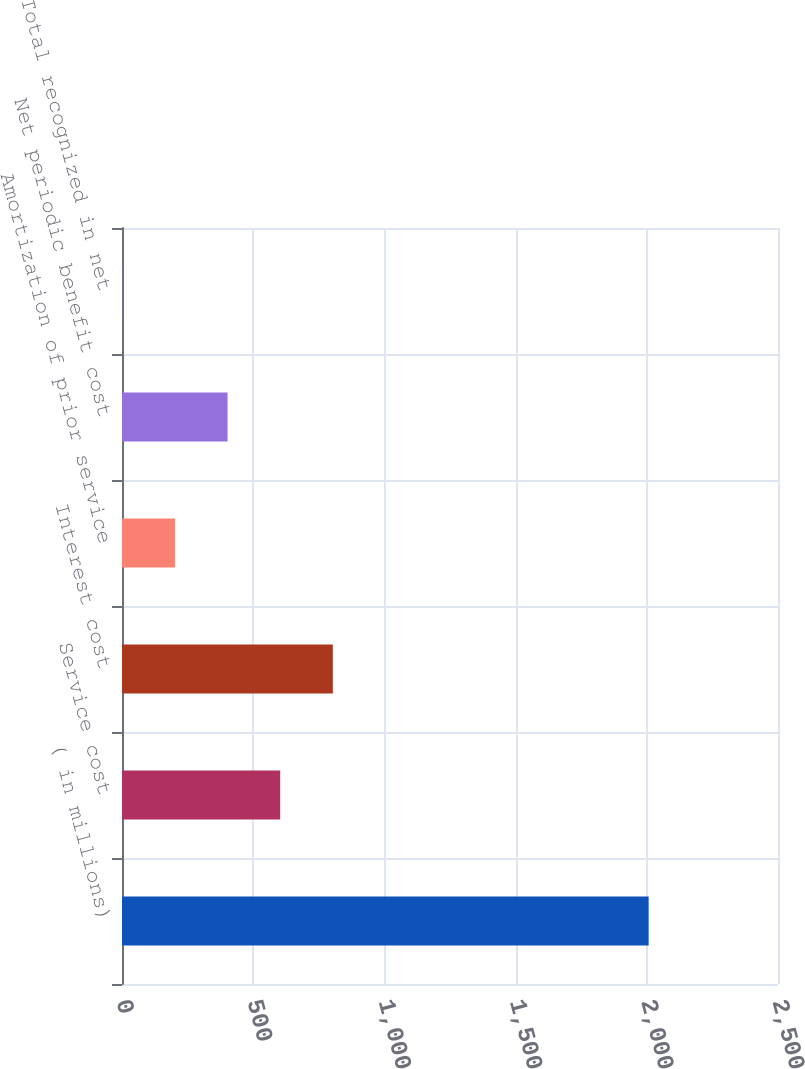Convert chart to OTSL. <chart><loc_0><loc_0><loc_500><loc_500><bar_chart><fcel>( in millions)<fcel>Service cost<fcel>Interest cost<fcel>Amortization of prior service<fcel>Net periodic benefit cost<fcel>Total recognized in net<nl><fcel>2007<fcel>602.87<fcel>803.46<fcel>201.69<fcel>402.28<fcel>1.1<nl></chart> 